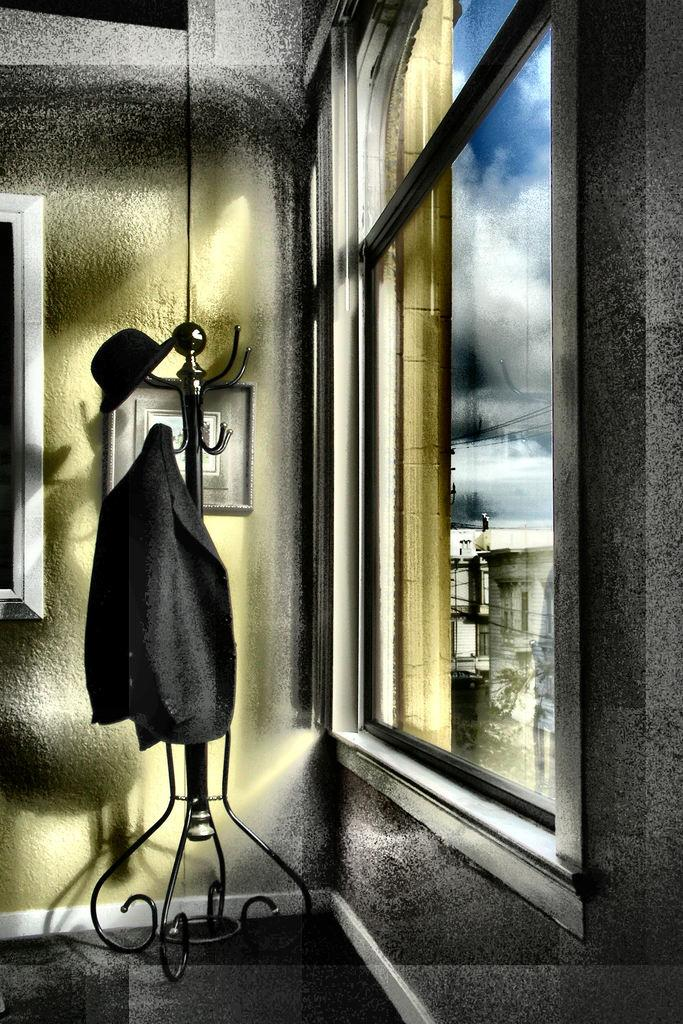What structure can be seen in the image? There is a stand in the image. What material is present in the image? There is cloth in the image. What accessory is visible in the image? There is a hat in the image. What architectural feature is present in the image? There is a wall in the image. What object is used to display items in the image? There is a frame in the image. What type of window is present in the image? There is a glass window in the image. What can be seen through the glass window? Buildings and the sky are visible through the glass window. What weather condition can be inferred from the image? Clouds are present in the sky, suggesting a partly cloudy day. How many ornaments are hanging from the hat in the image? There is no mention of ornaments in the image; the hat is simply visible. What decision can be made based on the presence of a bulb in the image? There is no mention of a bulb in the image, so no decision can be made based on its presence. 